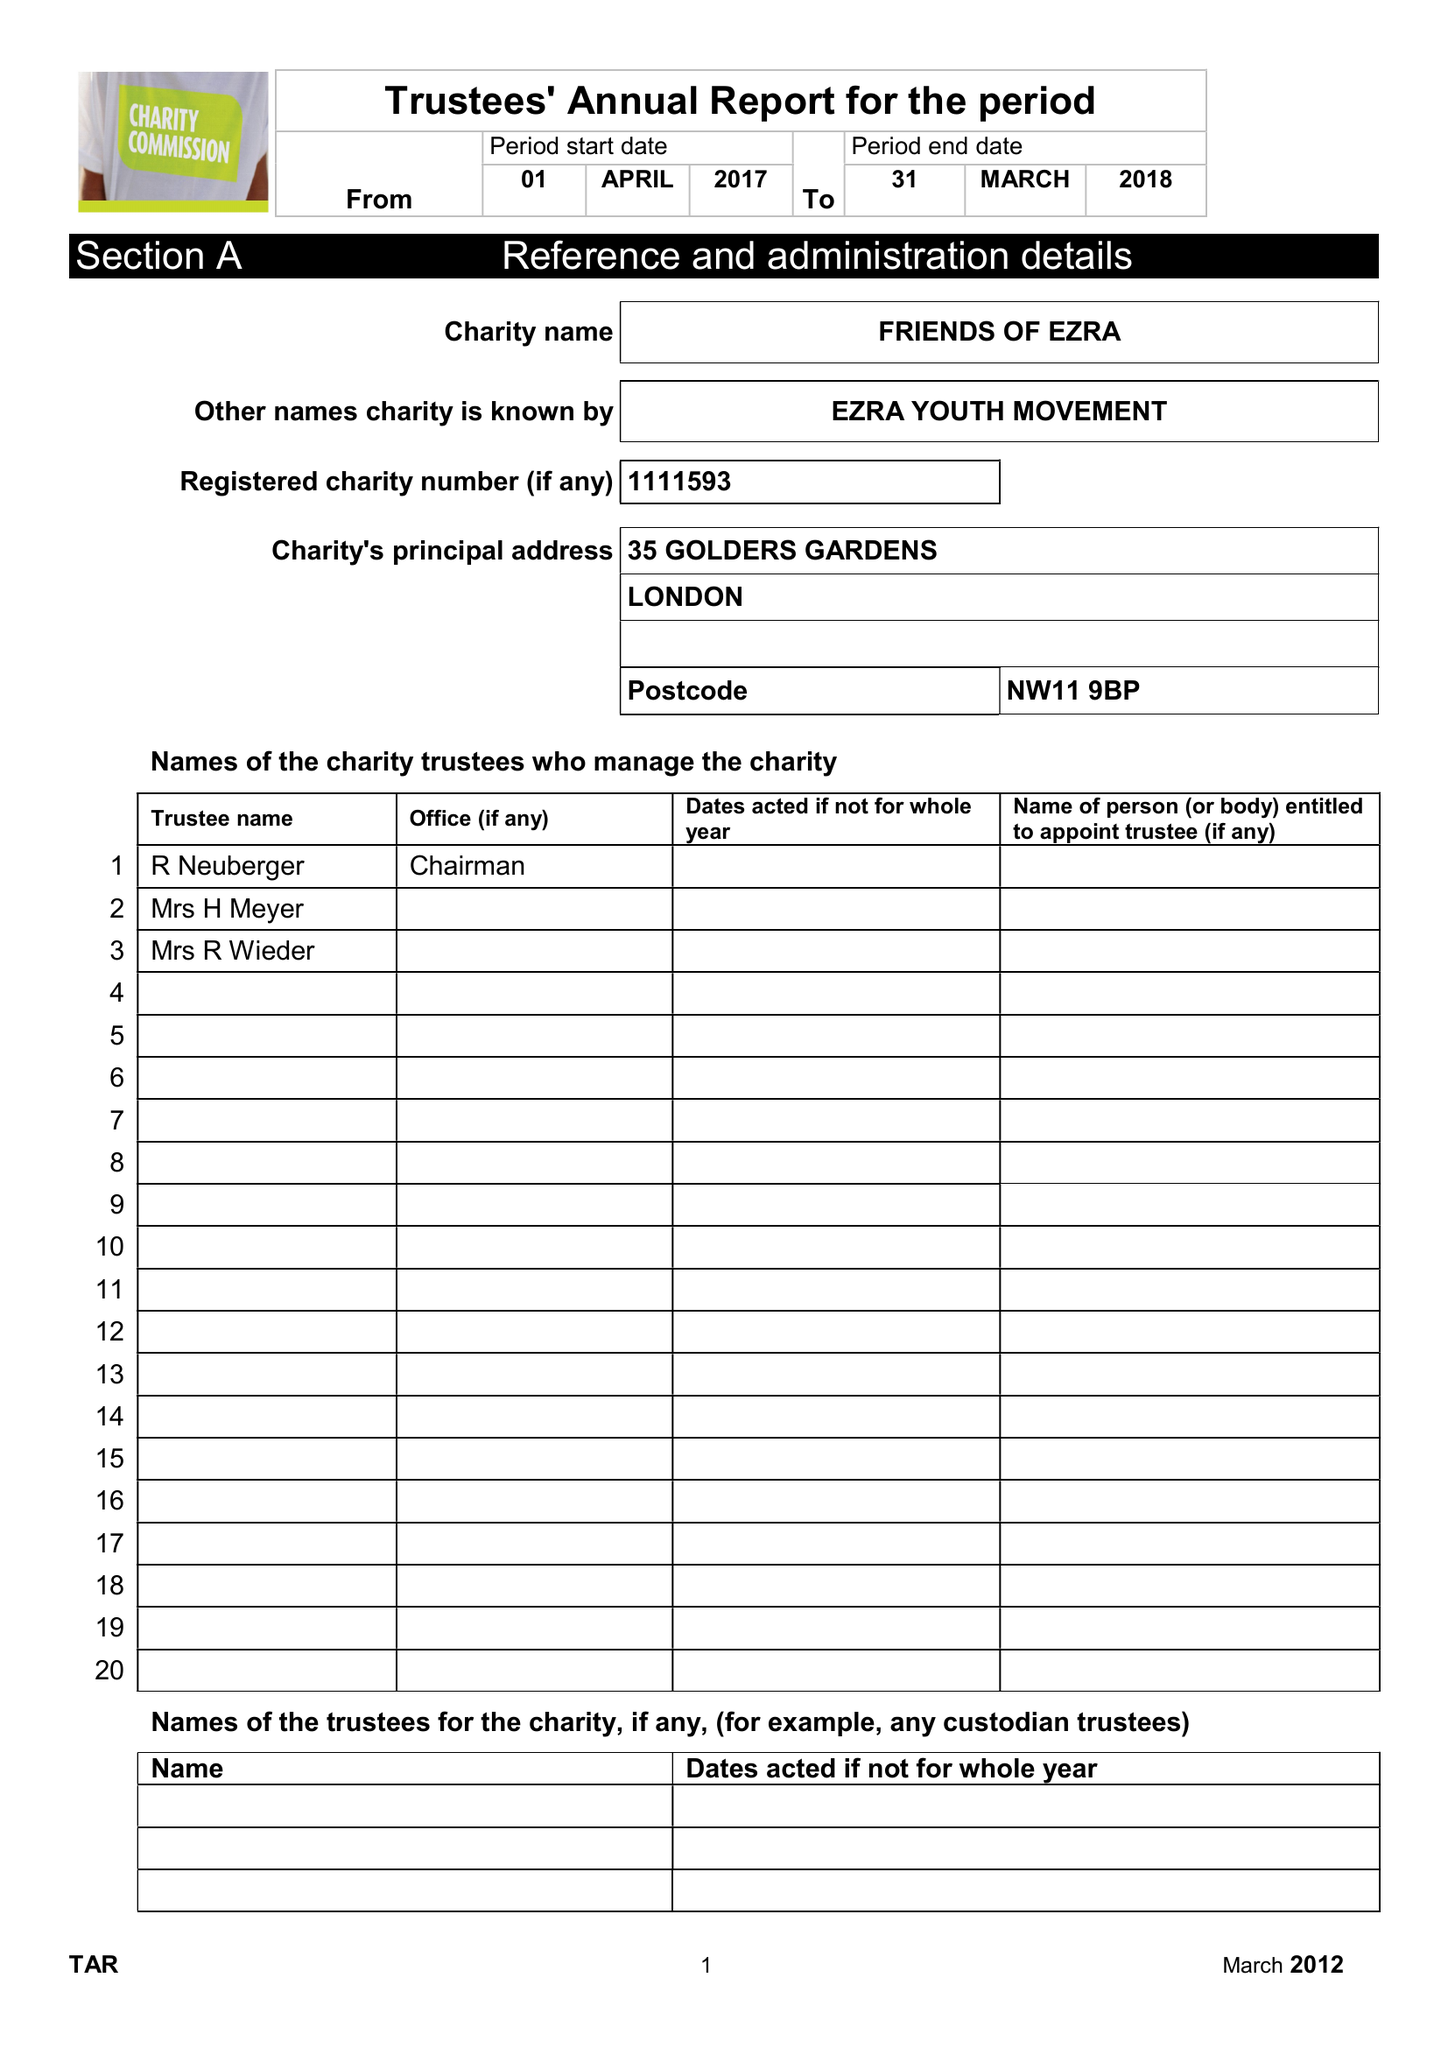What is the value for the address__street_line?
Answer the question using a single word or phrase. 35 GOLDERS GARDENS 